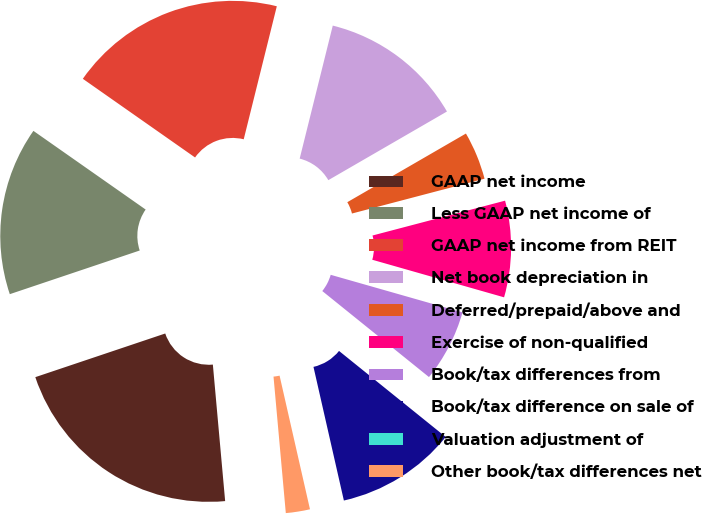Convert chart. <chart><loc_0><loc_0><loc_500><loc_500><pie_chart><fcel>GAAP net income<fcel>Less GAAP net income of<fcel>GAAP net income from REIT<fcel>Net book depreciation in<fcel>Deferred/prepaid/above and<fcel>Exercise of non-qualified<fcel>Book/tax differences from<fcel>Book/tax difference on sale of<fcel>Valuation adjustment of<fcel>Other book/tax differences net<nl><fcel>21.27%<fcel>14.89%<fcel>19.15%<fcel>12.77%<fcel>4.26%<fcel>8.51%<fcel>6.38%<fcel>10.64%<fcel>0.0%<fcel>2.13%<nl></chart> 